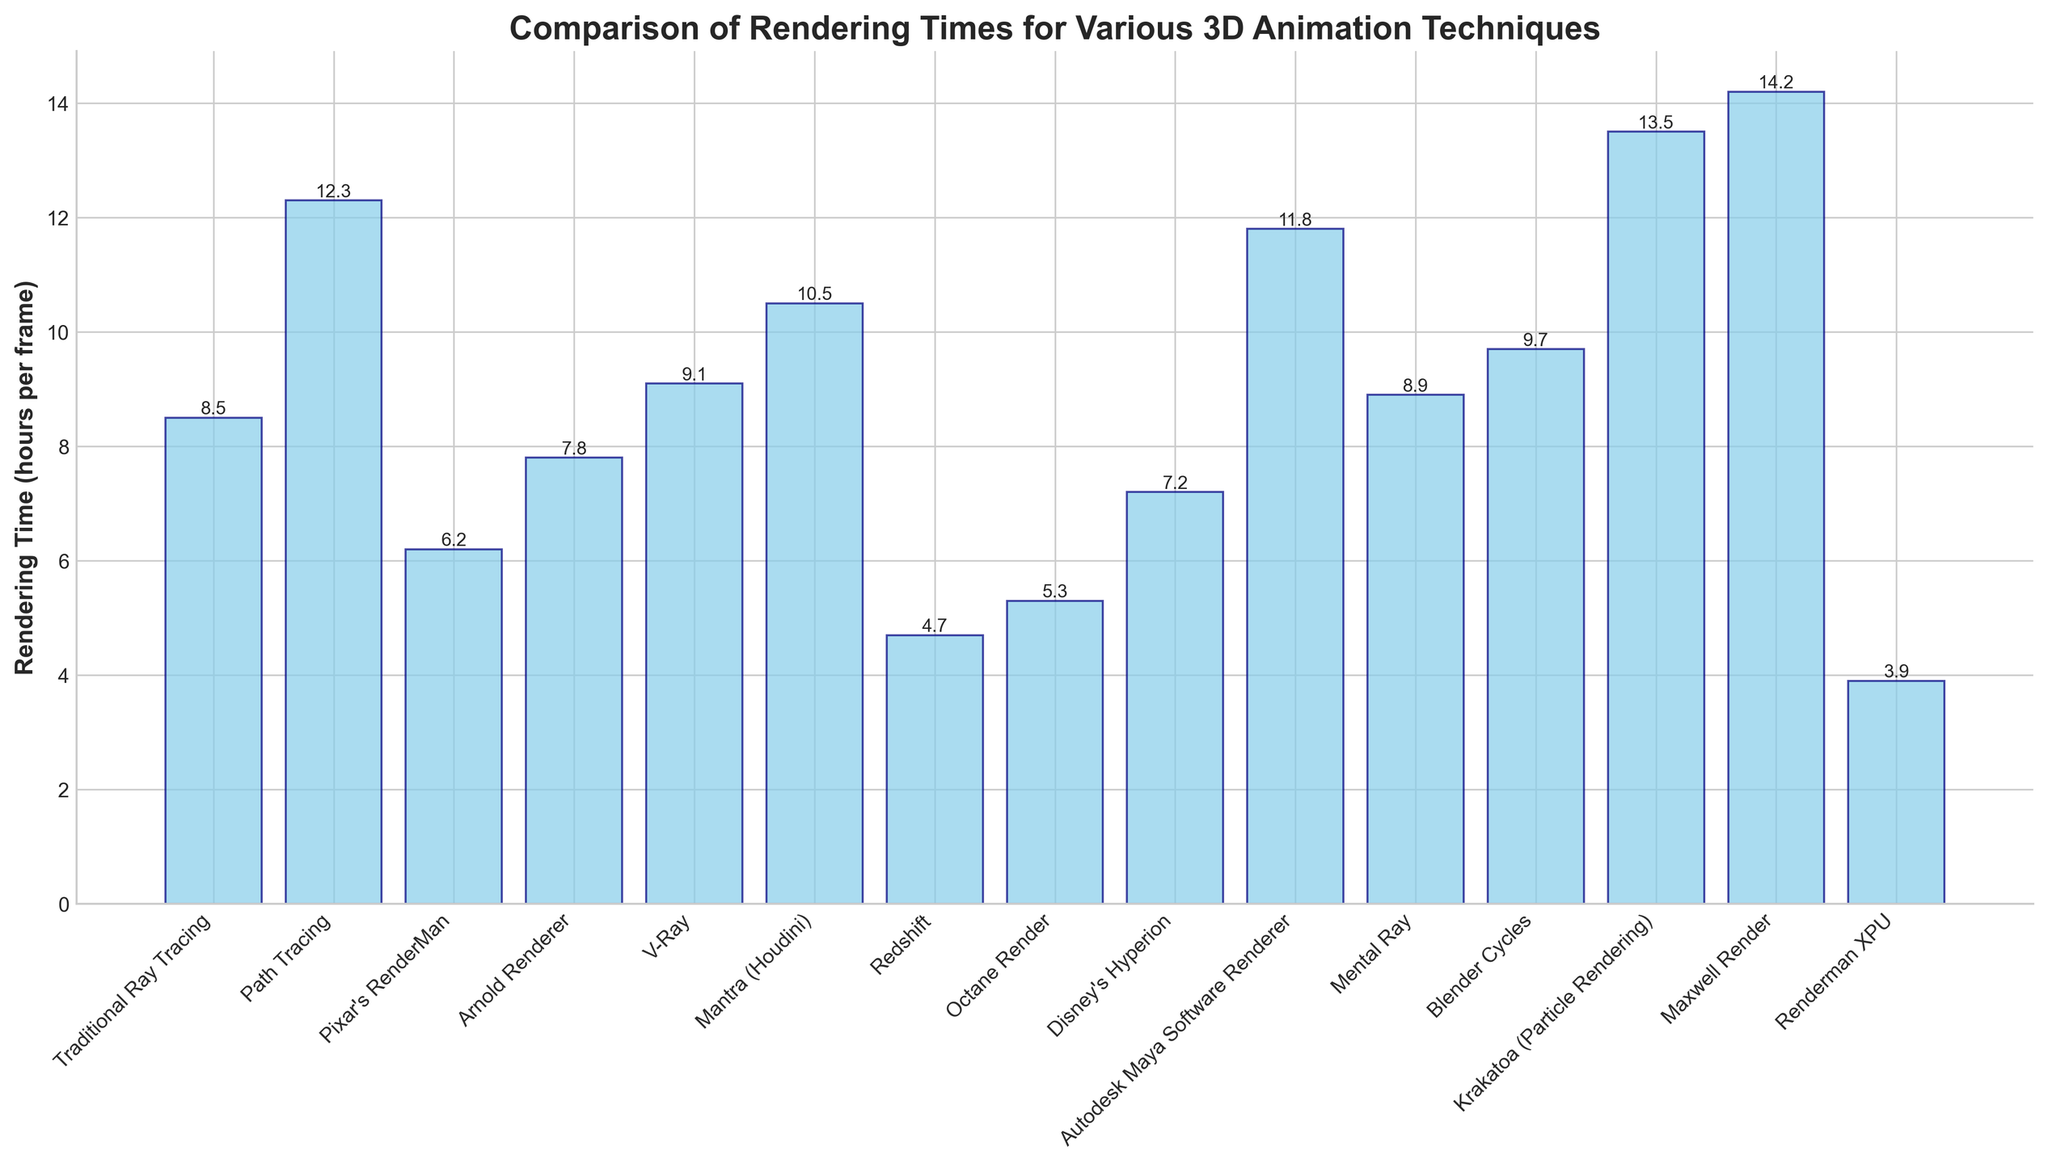Which technique has the shortest rendering time? To find the shortest rendering time, look for the bar with the smallest height. This corresponds to the Renderman XPU technique with a rendering time of 3.9 hours per frame.
Answer: Renderman XPU Which technique has the longest rendering time? To determine the longest rendering time, identify the bar with the greatest height. This bar corresponds to the Maxwell Render technique with 14.2 hours per frame.
Answer: Maxwell Render How much longer is the rendering time of Krakatoa compared to Redshift? To find the difference, subtract Redshift's rendering time from Krakatoa's: 13.5 - 4.7 = 8.8 hours.
Answer: 8.8 hours What is the rendering time difference between Pixar's RenderMan and Disney's Hyperion? Subtract Disney's Hyperion rendering time from Pixar's RenderMan: 7.2 - 6.2 = 1.0 hour.
Answer: 1.0 hour Which two techniques have rendering times closest to each other? Evaluate the differences between adjacent values: Arnold Renderer (7.8) and Disney's Hyperion (7.2) have a difference of 0.6 hours, which is the smallest.
Answer: Arnold Renderer and Disney's Hyperion What is the average rendering time across all techniques? Sum all rendering times and divide by the number of techniques: (8.5 + 12.3 + 6.2 + 7.8 + 9.1 + 10.5 + 4.7 + 5.3 + 7.2 + 11.8 + 8.9 + 9.7 + 13.5 + 14.2 + 3.9) / 15 ≈ 8.8 hours.
Answer: 8.8 hours Which technique is faster, V-Ray or Blender Cycles? Compare the heights of their bars; V-Ray's rendering time is 9.1 hours, while Blender Cycles' is 9.7 hours.
Answer: V-Ray How many techniques have a rendering time over 10 hours per frame? Count the number of bars with heights above 10: Path Tracing (12.3), Mantra (10.5), Autodesk Maya Software Renderer (11.8), Krakatoa (13.5), and Maxwell Render (14.2). There are 5 techniques.
Answer: 5 If you combine the rendering times of Traditional Ray Tracing and Arnold Renderer, what is the total? Add the rendering times of these two techniques: 8.5 + 7.8 = 16.3 hours.
Answer: 16.3 hours Is Path Tracing's rendering time greater than the sum of Renderman XPU and Redshift? Compare Path Tracing to the sum: 12.3 > (3.9 + 4.7) = 8.6 hours. Yes, Path Tracing is greater.
Answer: Yes 